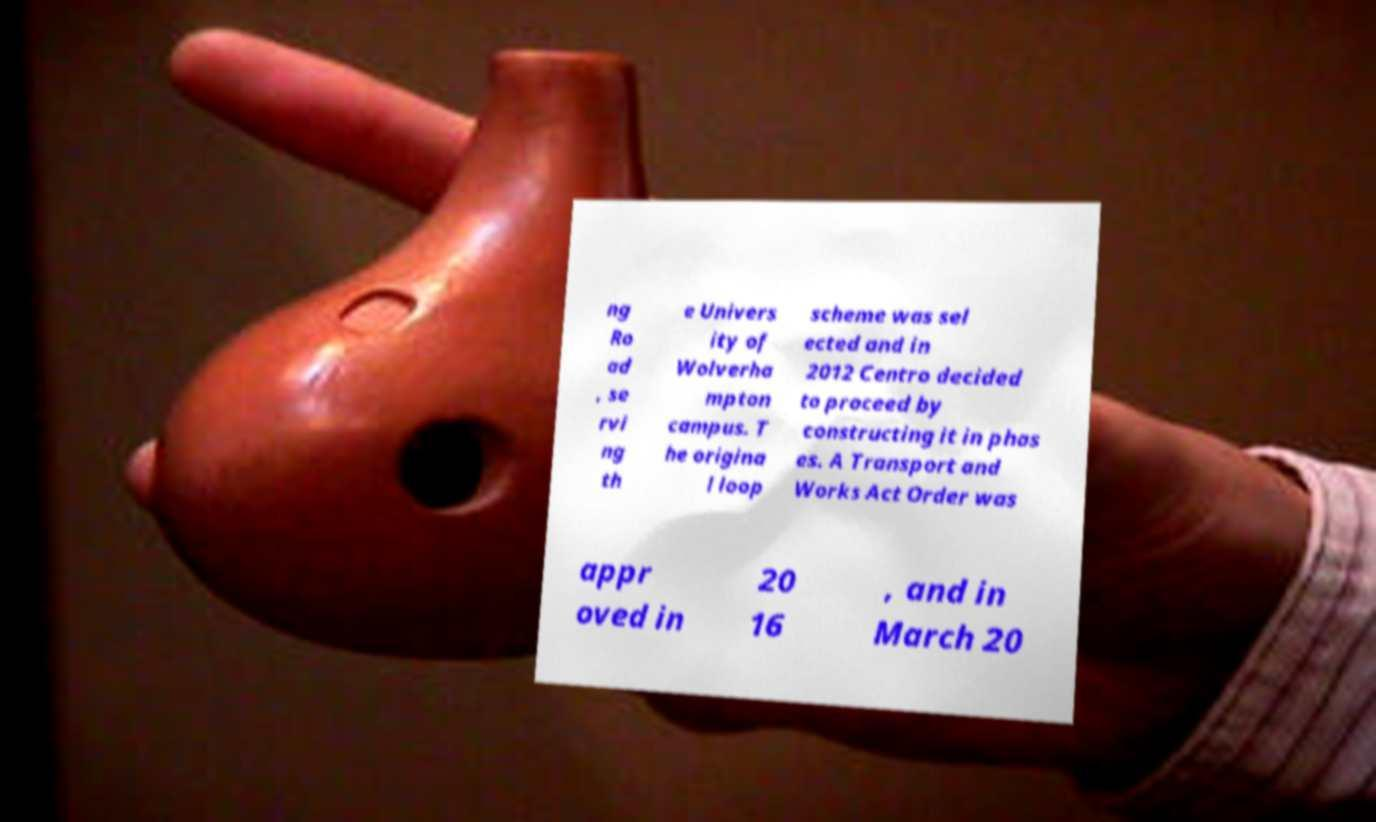Can you read and provide the text displayed in the image?This photo seems to have some interesting text. Can you extract and type it out for me? ng Ro ad , se rvi ng th e Univers ity of Wolverha mpton campus. T he origina l loop scheme was sel ected and in 2012 Centro decided to proceed by constructing it in phas es. A Transport and Works Act Order was appr oved in 20 16 , and in March 20 